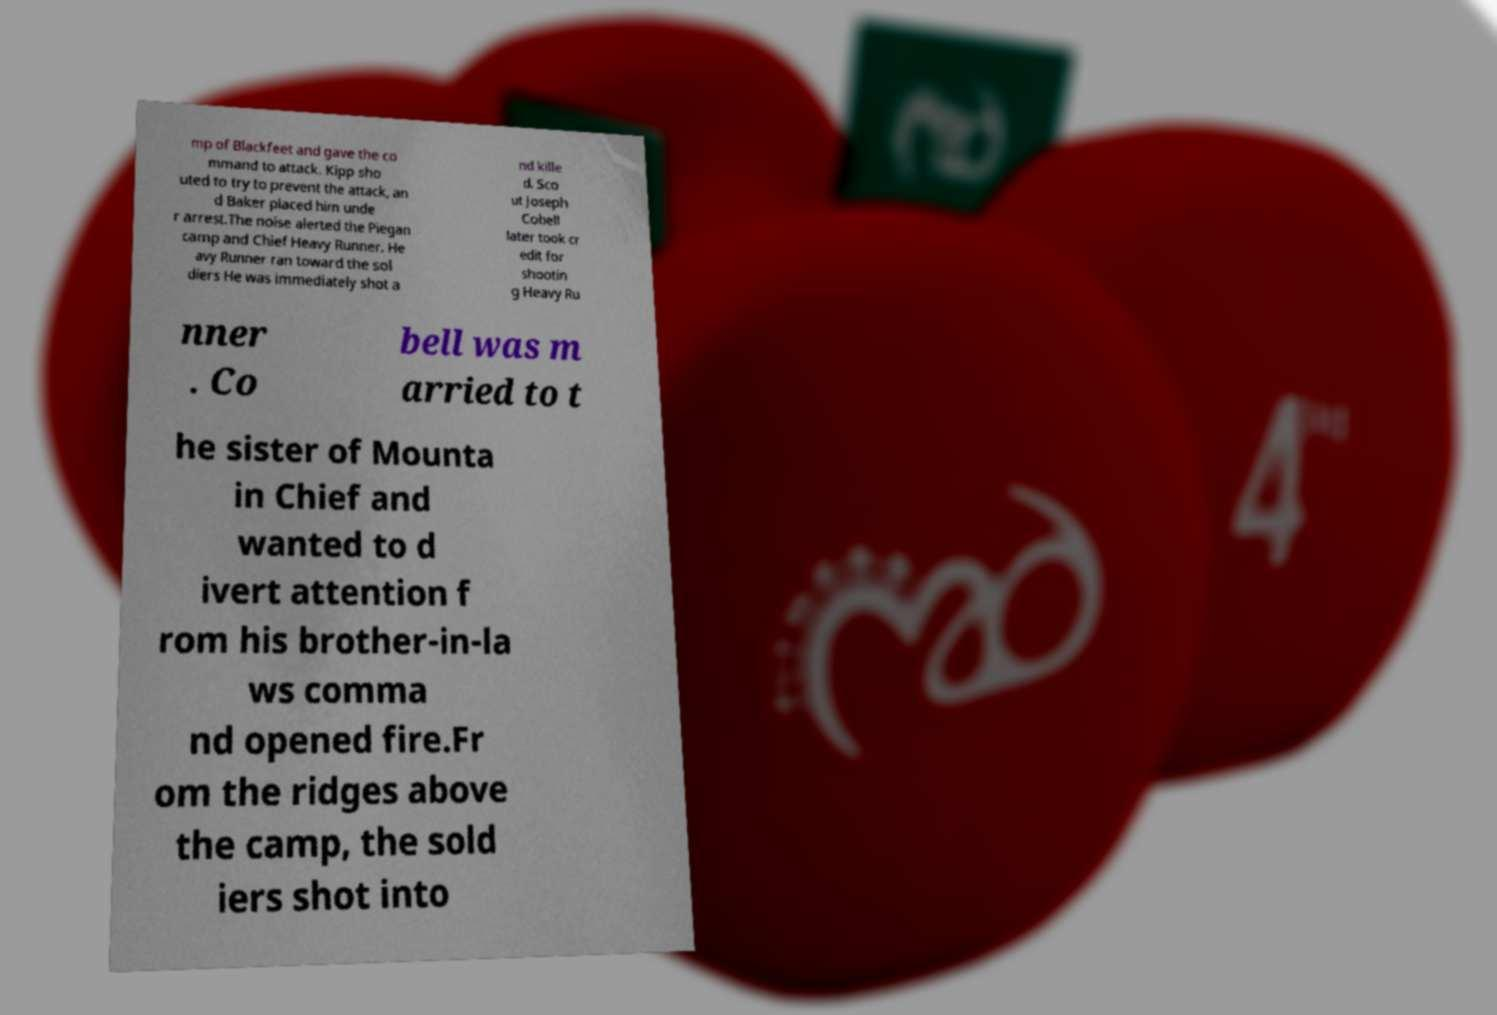Could you extract and type out the text from this image? mp of Blackfeet and gave the co mmand to attack. Kipp sho uted to try to prevent the attack, an d Baker placed him unde r arrest.The noise alerted the Piegan camp and Chief Heavy Runner. He avy Runner ran toward the sol diers He was immediately shot a nd kille d. Sco ut Joseph Cobell later took cr edit for shootin g Heavy Ru nner . Co bell was m arried to t he sister of Mounta in Chief and wanted to d ivert attention f rom his brother-in-la ws comma nd opened fire.Fr om the ridges above the camp, the sold iers shot into 